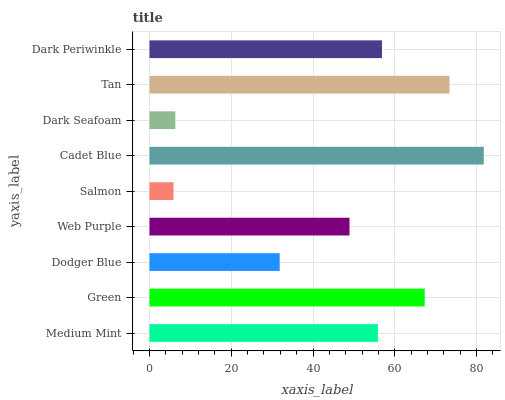Is Salmon the minimum?
Answer yes or no. Yes. Is Cadet Blue the maximum?
Answer yes or no. Yes. Is Green the minimum?
Answer yes or no. No. Is Green the maximum?
Answer yes or no. No. Is Green greater than Medium Mint?
Answer yes or no. Yes. Is Medium Mint less than Green?
Answer yes or no. Yes. Is Medium Mint greater than Green?
Answer yes or no. No. Is Green less than Medium Mint?
Answer yes or no. No. Is Medium Mint the high median?
Answer yes or no. Yes. Is Medium Mint the low median?
Answer yes or no. Yes. Is Dark Periwinkle the high median?
Answer yes or no. No. Is Salmon the low median?
Answer yes or no. No. 